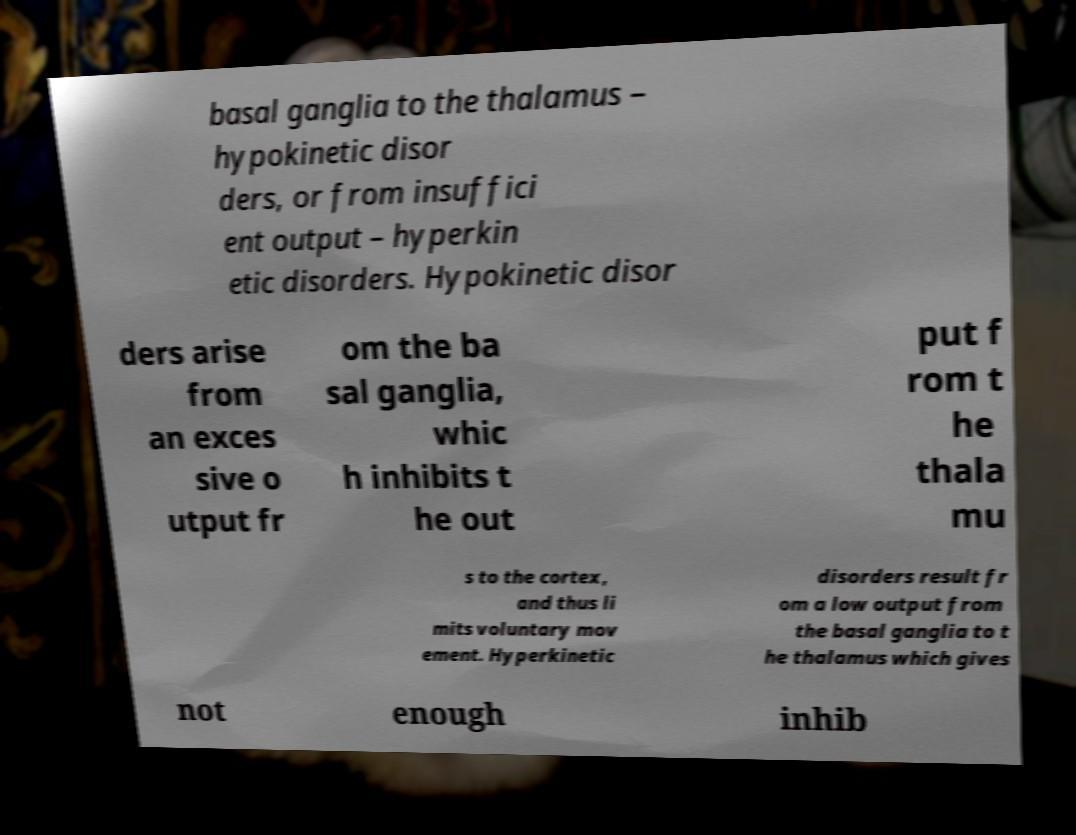Can you read and provide the text displayed in the image?This photo seems to have some interesting text. Can you extract and type it out for me? basal ganglia to the thalamus – hypokinetic disor ders, or from insuffici ent output – hyperkin etic disorders. Hypokinetic disor ders arise from an exces sive o utput fr om the ba sal ganglia, whic h inhibits t he out put f rom t he thala mu s to the cortex, and thus li mits voluntary mov ement. Hyperkinetic disorders result fr om a low output from the basal ganglia to t he thalamus which gives not enough inhib 